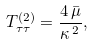Convert formula to latex. <formula><loc_0><loc_0><loc_500><loc_500>T _ { \tau \tau } ^ { ( 2 ) } = \frac { 4 \, \bar { \mu } } { \kappa ^ { \, 2 } } ,</formula> 